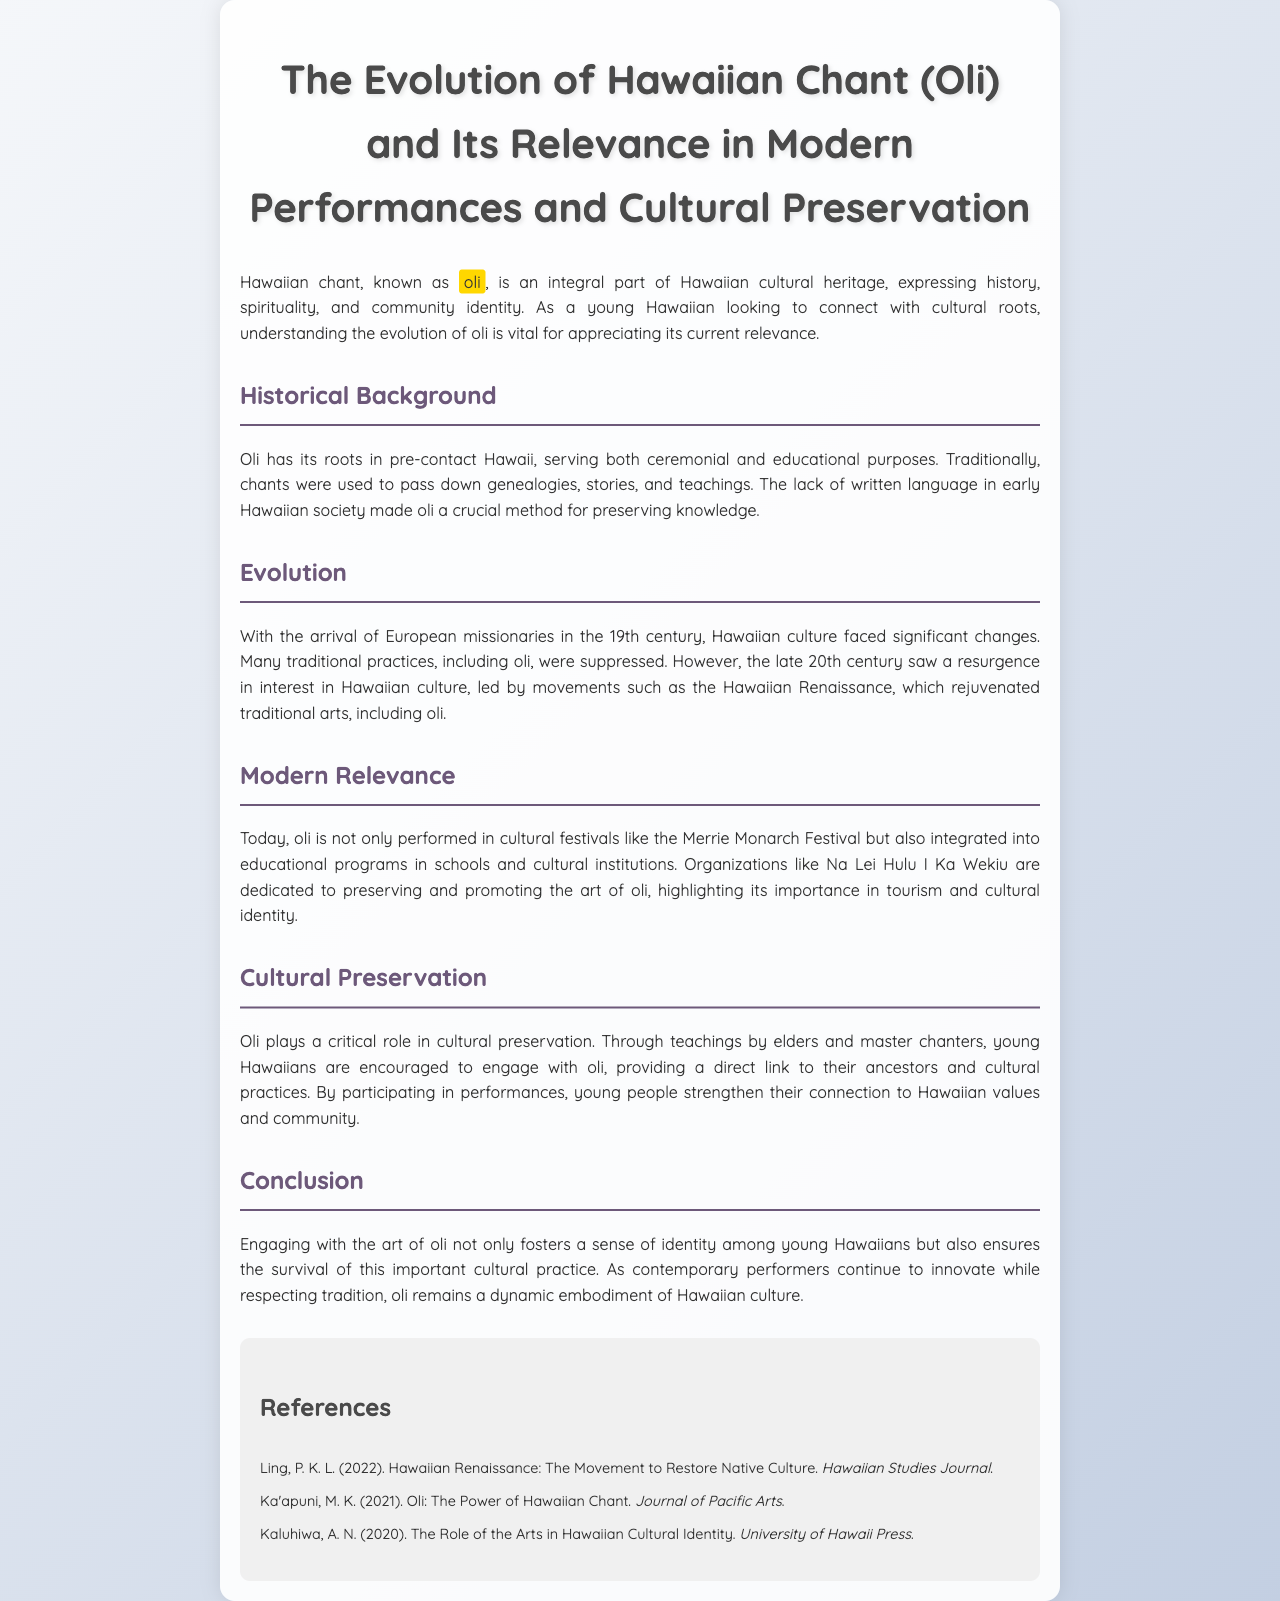What is Hawaiian chant known as? The document states that Hawaiian chant is known as "oli."
Answer: oli In which century did European missionaries arrive in Hawaii? The document mentions that European missionaries arrived in the 19th century.
Answer: 19th century What movement renewed interest in traditional arts like oli? According to the document, the Hawaiian Renaissance rejuvenated traditional arts, including oli.
Answer: Hawaiian Renaissance What cultural festival features the performance of oli? The document states that oli is performed at the Merrie Monarch Festival.
Answer: Merrie Monarch Festival What is the role of elders and master chanters in oli? The document explains that they teach young Hawaiians to engage with oli, connecting them to their ancestors and cultural practices.
Answer: Teach young Hawaiians How does engaging with oli affect young Hawaiians? The document suggests that engaging with the art of oli fosters a sense of identity among young Hawaiians.
Answer: Fosters a sense of identity What organization is dedicated to preserving and promoting the art of oli? The document refers to Na Lei Hulu I Ka Wekiu as the organization dedicated to this cause.
Answer: Na Lei Hulu I Ka Wekiu What does oli express as part of Hawaiian cultural heritage? The document states that oli expresses history, spirituality, and community identity.
Answer: History, spirituality, and community identity 